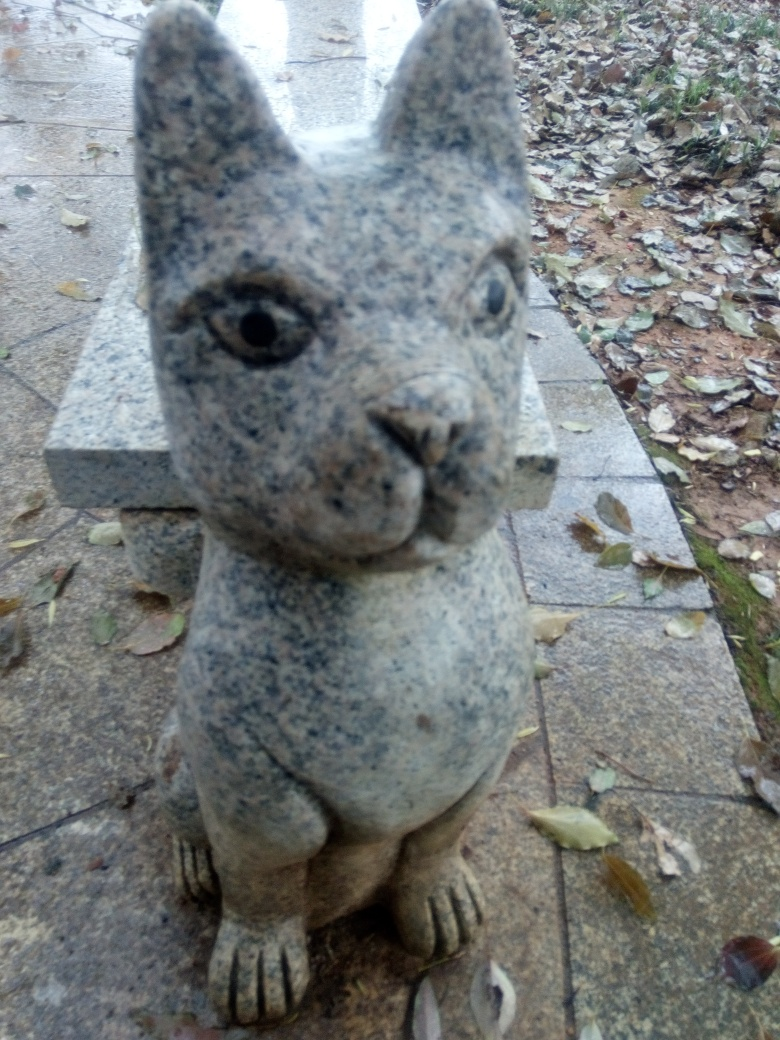What's the possible significance of this statue? Statues like this one often serve as decorative pieces in gardens or parks, providing a playful or whimsical element in the landscape. Additionally, it can also be a way to celebrate local wildlife, acting as a tribute to the natural inhabitants of the area where the statue is placed. 